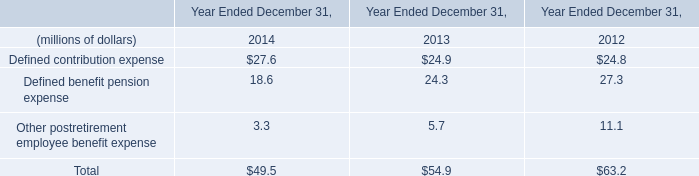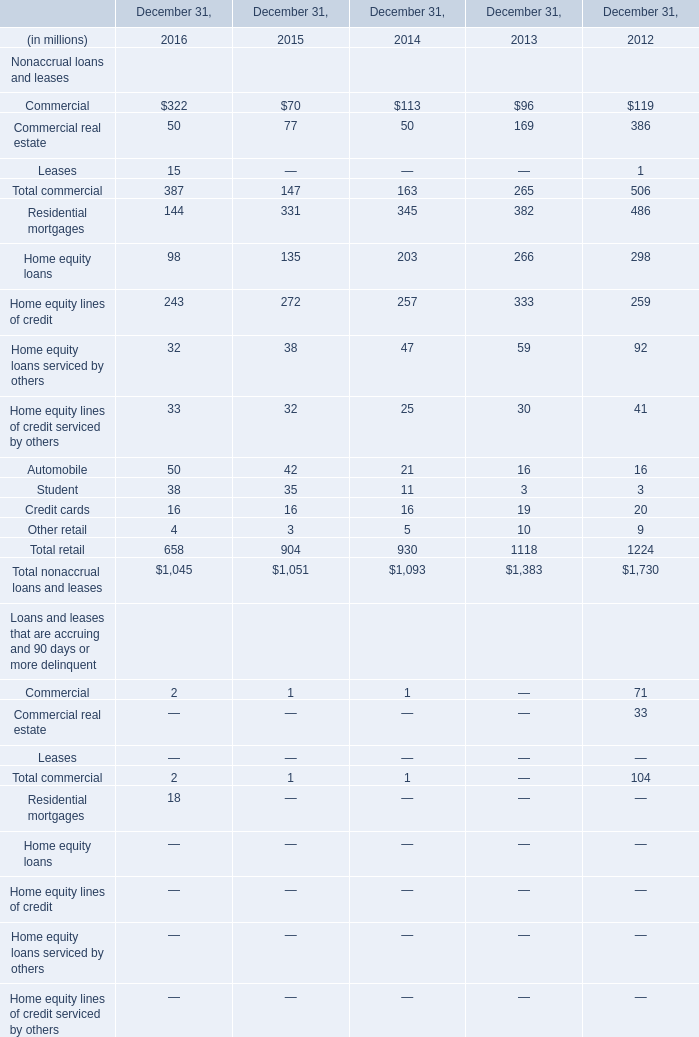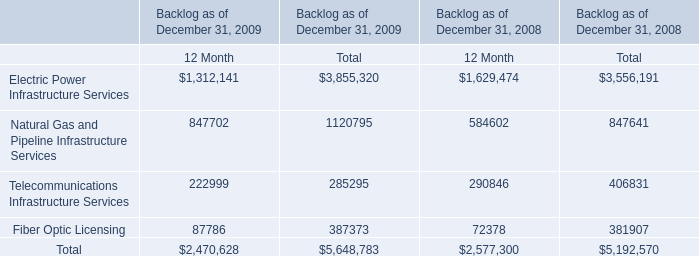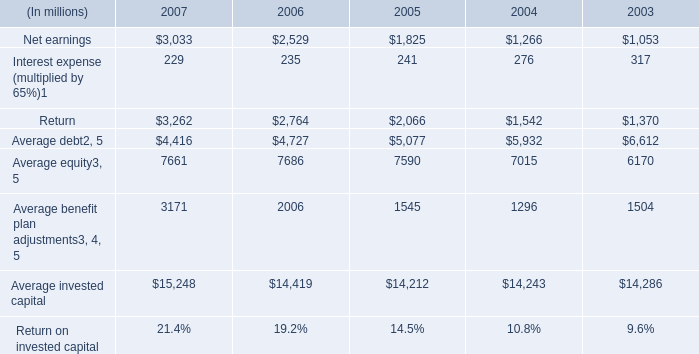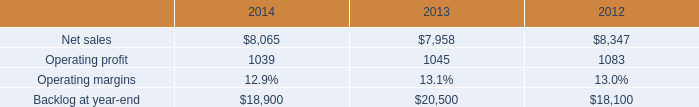What's the average of Average benefit plan adjustments of 2004, and Operating profit of 2012 ? 
Computations: ((1296.0 + 1083.0) / 2)
Answer: 1189.5. 